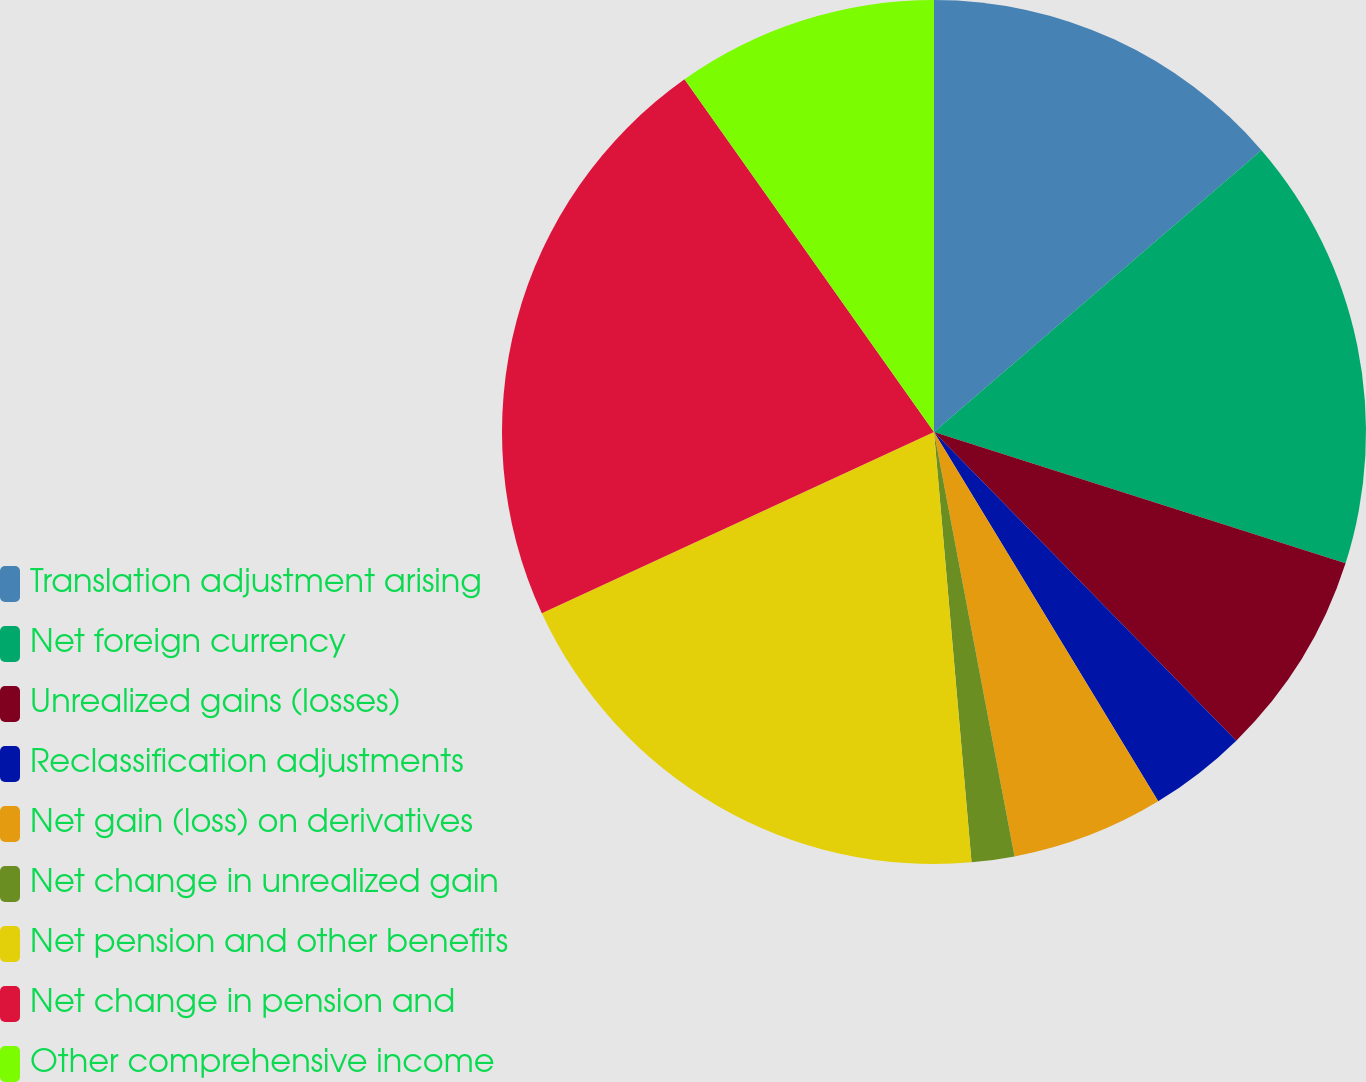<chart> <loc_0><loc_0><loc_500><loc_500><pie_chart><fcel>Translation adjustment arising<fcel>Net foreign currency<fcel>Unrealized gains (losses)<fcel>Reclassification adjustments<fcel>Net gain (loss) on derivatives<fcel>Net change in unrealized gain<fcel>Net pension and other benefits<fcel>Net change in pension and<fcel>Other comprehensive income<nl><fcel>13.69%<fcel>16.23%<fcel>7.75%<fcel>3.65%<fcel>5.7%<fcel>1.6%<fcel>19.5%<fcel>22.09%<fcel>9.8%<nl></chart> 